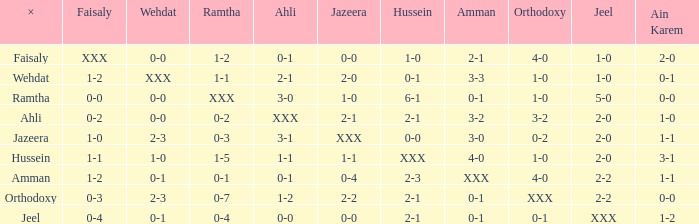What does ahli mean when ramtha has a score of 0-4? 0-0. Would you be able to parse every entry in this table? {'header': ['×', 'Faisaly', 'Wehdat', 'Ramtha', 'Ahli', 'Jazeera', 'Hussein', 'Amman', 'Orthodoxy', 'Jeel', 'Ain Karem'], 'rows': [['Faisaly', 'XXX', '0-0', '1-2', '0-1', '0-0', '1-0', '2-1', '4-0', '1-0', '2-0'], ['Wehdat', '1-2', 'XXX', '1-1', '2-1', '2-0', '0-1', '3-3', '1-0', '1-0', '0-1'], ['Ramtha', '0-0', '0-0', 'XXX', '3-0', '1-0', '6-1', '0-1', '1-0', '5-0', '0-0'], ['Ahli', '0-2', '0-0', '0-2', 'XXX', '2-1', '2-1', '3-2', '3-2', '2-0', '1-0'], ['Jazeera', '1-0', '2-3', '0-3', '3-1', 'XXX', '0-0', '3-0', '0-2', '2-0', '1-1'], ['Hussein', '1-1', '1-0', '1-5', '1-1', '1-1', 'XXX', '4-0', '1-0', '2-0', '3-1'], ['Amman', '1-2', '0-1', '0-1', '0-1', '0-4', '2-3', 'XXX', '4-0', '2-2', '1-1'], ['Orthodoxy', '0-3', '2-3', '0-7', '1-2', '2-2', '2-1', '0-1', 'XXX', '2-2', '0-0'], ['Jeel', '0-4', '0-1', '0-4', '0-0', '0-0', '2-1', '0-1', '0-1', 'XXX', '1-2']]} 